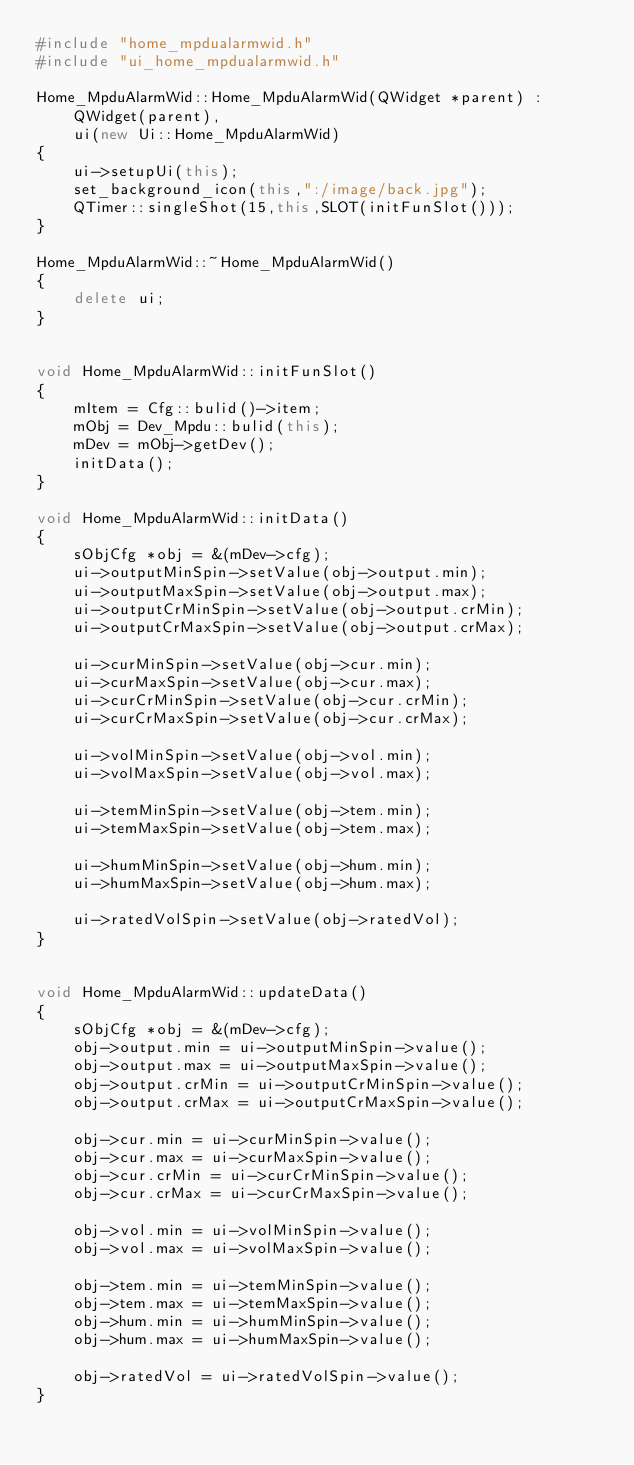Convert code to text. <code><loc_0><loc_0><loc_500><loc_500><_C++_>#include "home_mpdualarmwid.h"
#include "ui_home_mpdualarmwid.h"

Home_MpduAlarmWid::Home_MpduAlarmWid(QWidget *parent) :
    QWidget(parent),
    ui(new Ui::Home_MpduAlarmWid)
{
    ui->setupUi(this);
    set_background_icon(this,":/image/back.jpg");
    QTimer::singleShot(15,this,SLOT(initFunSlot()));
}

Home_MpduAlarmWid::~Home_MpduAlarmWid()
{
    delete ui;
}


void Home_MpduAlarmWid::initFunSlot()
{
    mItem = Cfg::bulid()->item;
    mObj = Dev_Mpdu::bulid(this);
    mDev = mObj->getDev();
    initData();
}

void Home_MpduAlarmWid::initData()
{
    sObjCfg *obj = &(mDev->cfg);
    ui->outputMinSpin->setValue(obj->output.min);
    ui->outputMaxSpin->setValue(obj->output.max);
    ui->outputCrMinSpin->setValue(obj->output.crMin);
    ui->outputCrMaxSpin->setValue(obj->output.crMax);

    ui->curMinSpin->setValue(obj->cur.min);
    ui->curMaxSpin->setValue(obj->cur.max);
    ui->curCrMinSpin->setValue(obj->cur.crMin);
    ui->curCrMaxSpin->setValue(obj->cur.crMax);

    ui->volMinSpin->setValue(obj->vol.min);
    ui->volMaxSpin->setValue(obj->vol.max);

    ui->temMinSpin->setValue(obj->tem.min);
    ui->temMaxSpin->setValue(obj->tem.max);

    ui->humMinSpin->setValue(obj->hum.min);
    ui->humMaxSpin->setValue(obj->hum.max);

    ui->ratedVolSpin->setValue(obj->ratedVol);
}


void Home_MpduAlarmWid::updateData()
{
    sObjCfg *obj = &(mDev->cfg);
    obj->output.min = ui->outputMinSpin->value();
    obj->output.max = ui->outputMaxSpin->value();
    obj->output.crMin = ui->outputCrMinSpin->value();
    obj->output.crMax = ui->outputCrMaxSpin->value();

    obj->cur.min = ui->curMinSpin->value();
    obj->cur.max = ui->curMaxSpin->value();
    obj->cur.crMin = ui->curCrMinSpin->value();
    obj->cur.crMax = ui->curCrMaxSpin->value();

    obj->vol.min = ui->volMinSpin->value();
    obj->vol.max = ui->volMaxSpin->value();

    obj->tem.min = ui->temMinSpin->value();
    obj->tem.max = ui->temMaxSpin->value();
    obj->hum.min = ui->humMinSpin->value();
    obj->hum.max = ui->humMaxSpin->value();

    obj->ratedVol = ui->ratedVolSpin->value();
}
</code> 